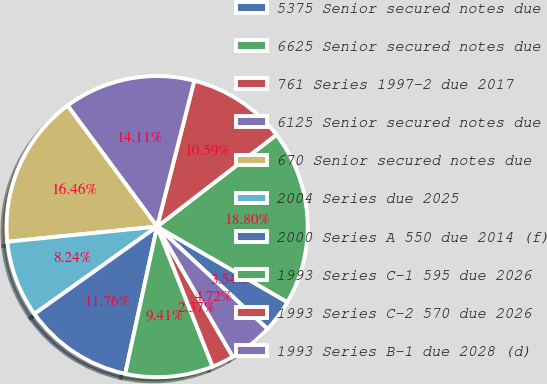<chart> <loc_0><loc_0><loc_500><loc_500><pie_chart><fcel>5375 Senior secured notes due<fcel>6625 Senior secured notes due<fcel>761 Series 1997-2 due 2017<fcel>6125 Senior secured notes due<fcel>670 Senior secured notes due<fcel>2004 Series due 2025<fcel>2000 Series A 550 due 2014 (f)<fcel>1993 Series C-1 595 due 2026<fcel>1993 Series C-2 570 due 2026<fcel>1993 Series B-1 due 2028 (d)<nl><fcel>3.54%<fcel>18.8%<fcel>10.59%<fcel>14.11%<fcel>16.46%<fcel>8.24%<fcel>11.76%<fcel>9.41%<fcel>2.37%<fcel>4.72%<nl></chart> 